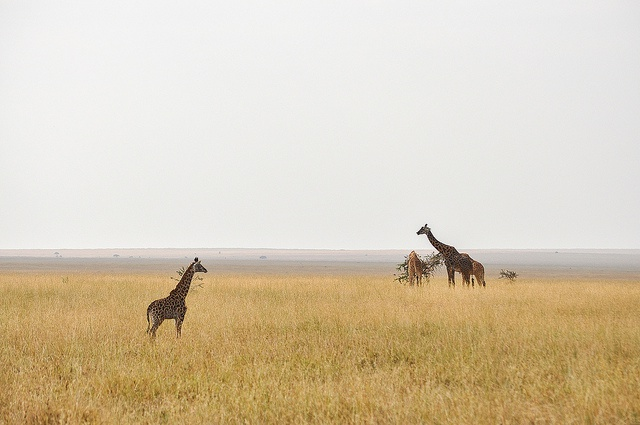Describe the objects in this image and their specific colors. I can see giraffe in white, black, maroon, and gray tones, giraffe in white, black, maroon, and gray tones, giraffe in white, gray, maroon, and brown tones, and giraffe in white, maroon, and gray tones in this image. 